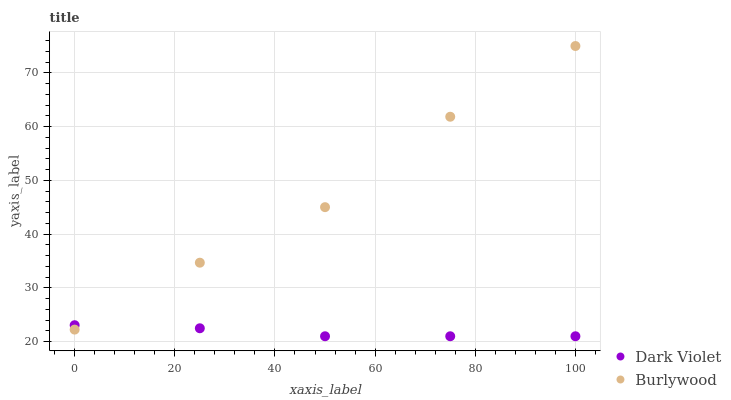Does Dark Violet have the minimum area under the curve?
Answer yes or no. Yes. Does Burlywood have the maximum area under the curve?
Answer yes or no. Yes. Does Dark Violet have the maximum area under the curve?
Answer yes or no. No. Is Dark Violet the smoothest?
Answer yes or no. Yes. Is Burlywood the roughest?
Answer yes or no. Yes. Is Dark Violet the roughest?
Answer yes or no. No. Does Dark Violet have the lowest value?
Answer yes or no. Yes. Does Burlywood have the highest value?
Answer yes or no. Yes. Does Dark Violet have the highest value?
Answer yes or no. No. Does Dark Violet intersect Burlywood?
Answer yes or no. Yes. Is Dark Violet less than Burlywood?
Answer yes or no. No. Is Dark Violet greater than Burlywood?
Answer yes or no. No. 